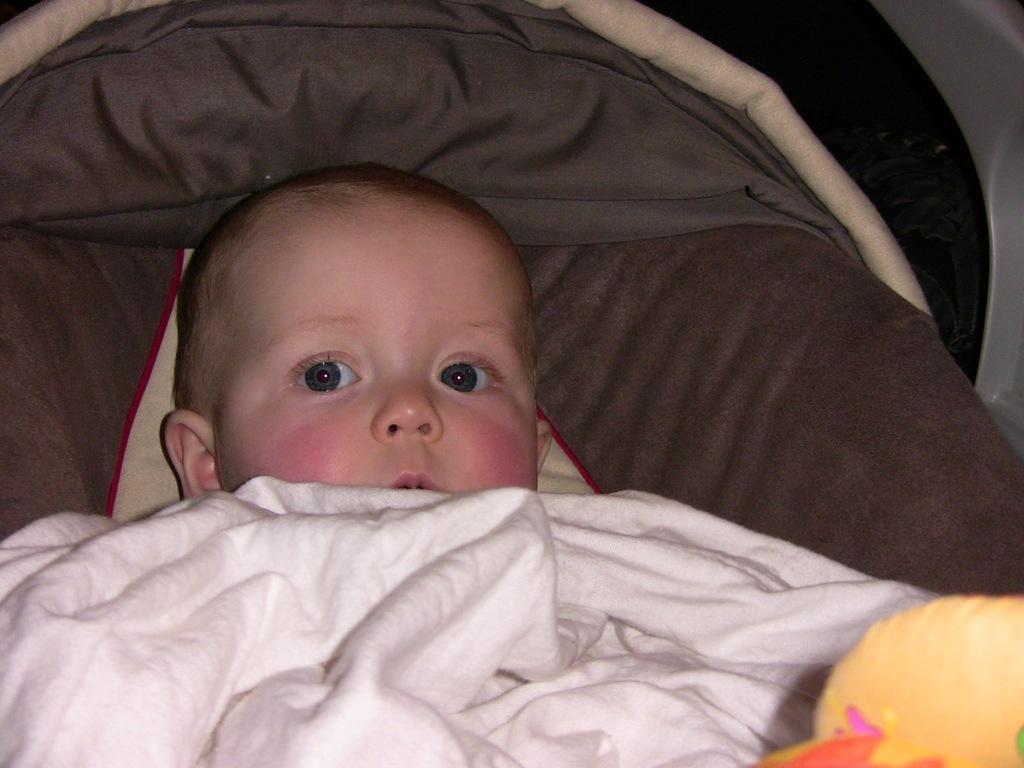Describe this image in one or two sentences. In this image I can see a baby, a white cloth and a yellow colour thing. I can also see few more clothes over here. 